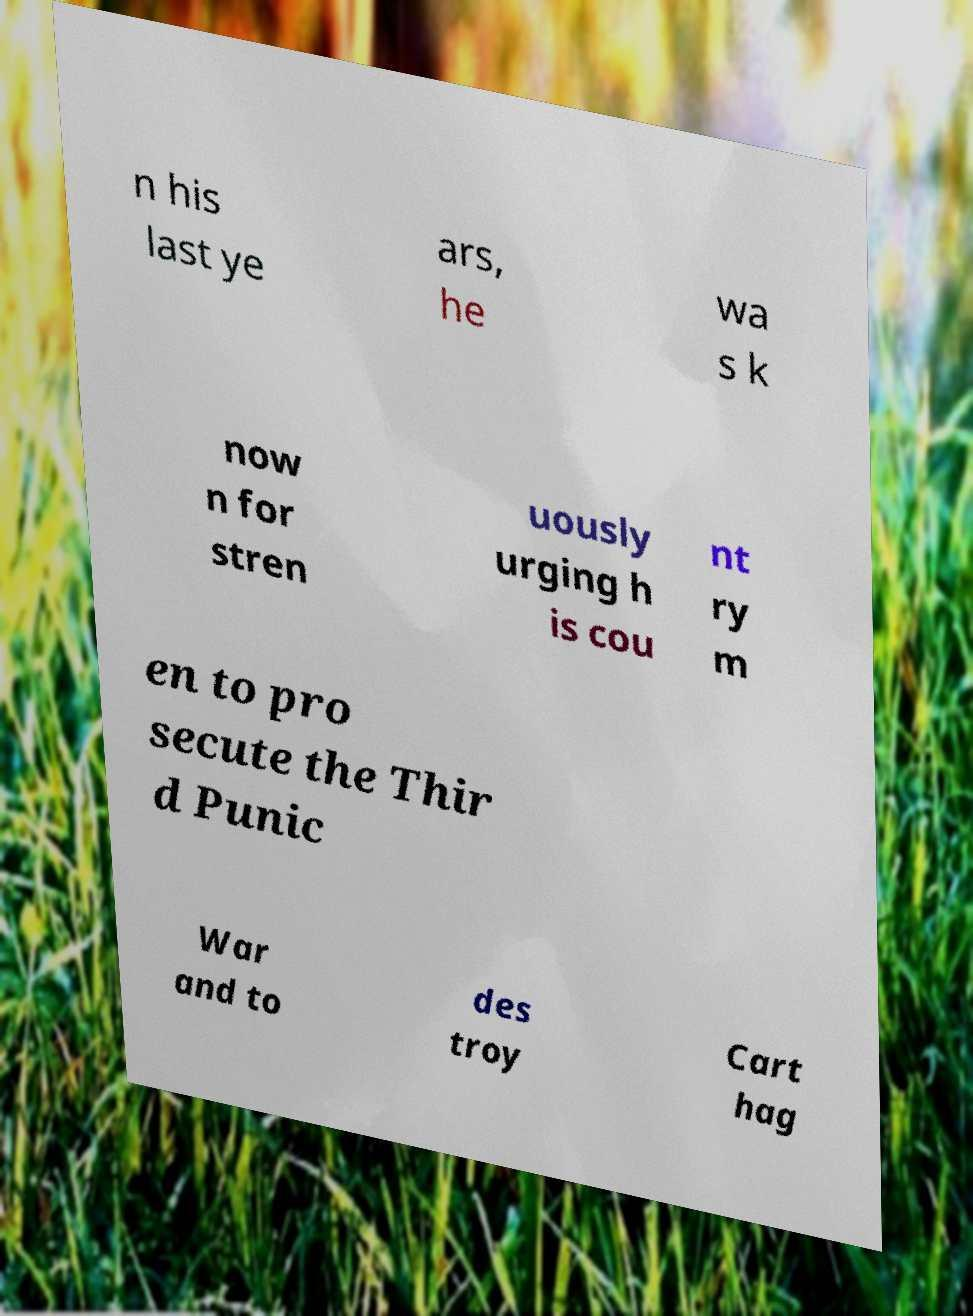What messages or text are displayed in this image? I need them in a readable, typed format. n his last ye ars, he wa s k now n for stren uously urging h is cou nt ry m en to pro secute the Thir d Punic War and to des troy Cart hag 